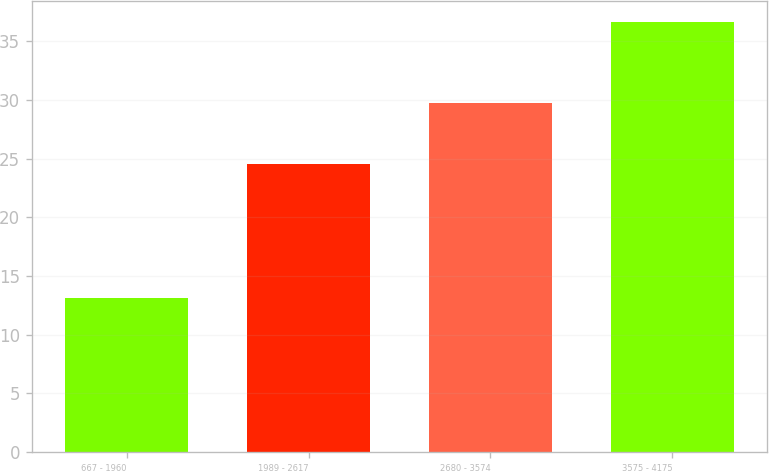<chart> <loc_0><loc_0><loc_500><loc_500><bar_chart><fcel>667 - 1960<fcel>1989 - 2617<fcel>2680 - 3574<fcel>3575 - 4175<nl><fcel>13.15<fcel>24.55<fcel>29.69<fcel>36.6<nl></chart> 